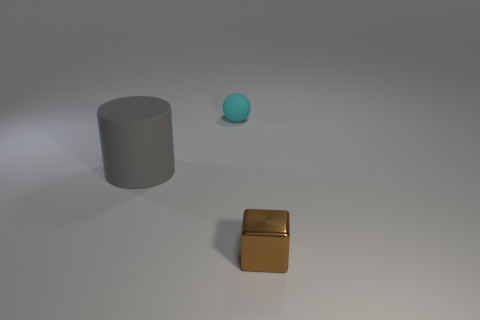What number of things are either tiny brown metal blocks that are in front of the small cyan object or gray shiny objects?
Your response must be concise. 1. There is a object that is to the right of the small thing that is behind the brown shiny object; what is it made of?
Ensure brevity in your answer.  Metal. Are there any big blue cubes that have the same material as the cyan ball?
Offer a terse response. No. Are there any big gray matte objects that are on the right side of the thing that is on the right side of the tiny rubber thing?
Your answer should be very brief. No. There is a small brown cube that is in front of the small rubber sphere; what is it made of?
Provide a succinct answer. Metal. Is the brown thing the same shape as the cyan matte thing?
Provide a short and direct response. No. There is a object that is right of the tiny thing behind the tiny cube in front of the big matte cylinder; what is its color?
Offer a very short reply. Brown. How many other gray things have the same shape as the large thing?
Ensure brevity in your answer.  0. There is a matte object that is in front of the small thing to the left of the tiny brown metallic cube; what size is it?
Your response must be concise. Large. Is the metallic cube the same size as the gray cylinder?
Provide a short and direct response. No. 